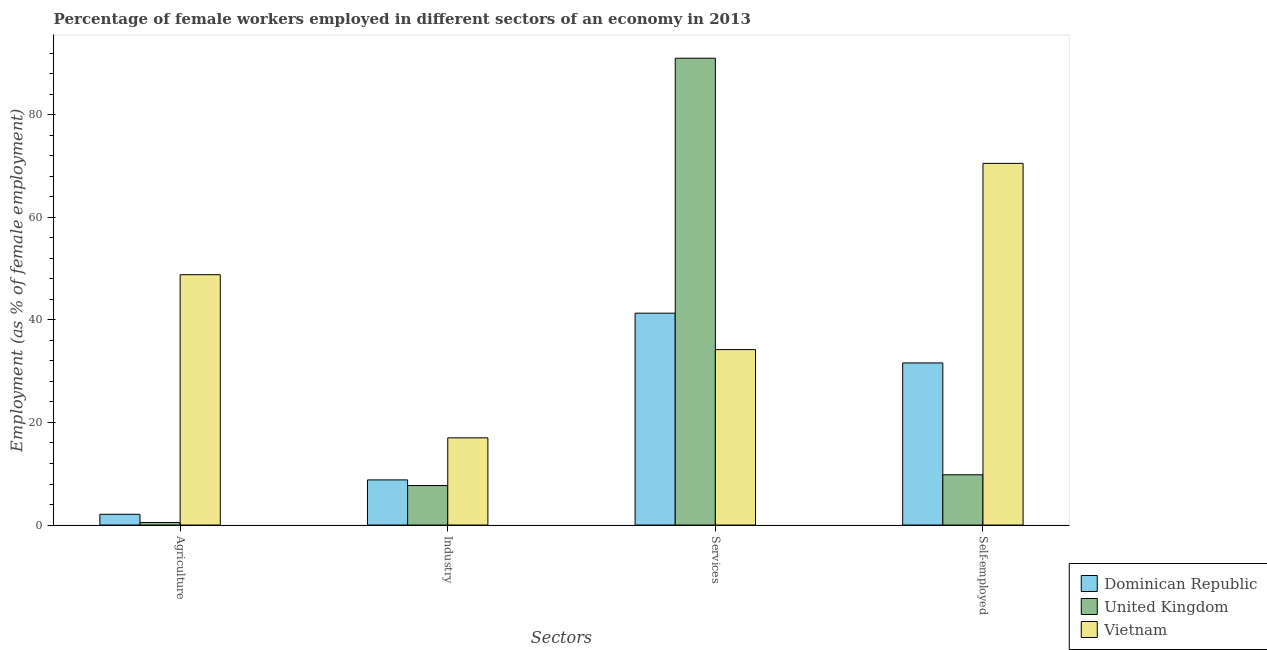Are the number of bars on each tick of the X-axis equal?
Your answer should be very brief. Yes. How many bars are there on the 3rd tick from the left?
Provide a short and direct response. 3. What is the label of the 4th group of bars from the left?
Your response must be concise. Self-employed. What is the percentage of female workers in services in Dominican Republic?
Your answer should be compact. 41.3. Across all countries, what is the maximum percentage of female workers in industry?
Provide a succinct answer. 17. Across all countries, what is the minimum percentage of female workers in agriculture?
Make the answer very short. 0.5. In which country was the percentage of female workers in services maximum?
Provide a short and direct response. United Kingdom. What is the total percentage of female workers in agriculture in the graph?
Your answer should be compact. 51.4. What is the difference between the percentage of female workers in agriculture in United Kingdom and that in Dominican Republic?
Provide a succinct answer. -1.6. What is the difference between the percentage of female workers in industry in Vietnam and the percentage of female workers in agriculture in United Kingdom?
Provide a short and direct response. 16.5. What is the average percentage of female workers in agriculture per country?
Your answer should be very brief. 17.13. What is the difference between the percentage of female workers in services and percentage of female workers in agriculture in Dominican Republic?
Offer a very short reply. 39.2. In how many countries, is the percentage of female workers in industry greater than 80 %?
Your answer should be very brief. 0. What is the ratio of the percentage of self employed female workers in Dominican Republic to that in Vietnam?
Offer a very short reply. 0.45. Is the percentage of self employed female workers in United Kingdom less than that in Dominican Republic?
Your response must be concise. Yes. What is the difference between the highest and the second highest percentage of female workers in services?
Ensure brevity in your answer.  49.7. What is the difference between the highest and the lowest percentage of female workers in services?
Your answer should be very brief. 56.8. In how many countries, is the percentage of self employed female workers greater than the average percentage of self employed female workers taken over all countries?
Your response must be concise. 1. Is the sum of the percentage of female workers in agriculture in Vietnam and United Kingdom greater than the maximum percentage of female workers in services across all countries?
Offer a very short reply. No. Is it the case that in every country, the sum of the percentage of female workers in services and percentage of female workers in industry is greater than the sum of percentage of self employed female workers and percentage of female workers in agriculture?
Provide a succinct answer. No. What does the 1st bar from the left in Industry represents?
Offer a very short reply. Dominican Republic. What does the 3rd bar from the right in Industry represents?
Your response must be concise. Dominican Republic. Is it the case that in every country, the sum of the percentage of female workers in agriculture and percentage of female workers in industry is greater than the percentage of female workers in services?
Your answer should be compact. No. How many bars are there?
Your answer should be compact. 12. Are all the bars in the graph horizontal?
Offer a very short reply. No. What is the difference between two consecutive major ticks on the Y-axis?
Offer a terse response. 20. Are the values on the major ticks of Y-axis written in scientific E-notation?
Your answer should be compact. No. Does the graph contain any zero values?
Your answer should be compact. No. Does the graph contain grids?
Your answer should be compact. No. Where does the legend appear in the graph?
Make the answer very short. Bottom right. How many legend labels are there?
Your answer should be very brief. 3. What is the title of the graph?
Your response must be concise. Percentage of female workers employed in different sectors of an economy in 2013. Does "World" appear as one of the legend labels in the graph?
Offer a very short reply. No. What is the label or title of the X-axis?
Your answer should be compact. Sectors. What is the label or title of the Y-axis?
Offer a very short reply. Employment (as % of female employment). What is the Employment (as % of female employment) in Dominican Republic in Agriculture?
Offer a terse response. 2.1. What is the Employment (as % of female employment) in Vietnam in Agriculture?
Offer a very short reply. 48.8. What is the Employment (as % of female employment) of Dominican Republic in Industry?
Make the answer very short. 8.8. What is the Employment (as % of female employment) in United Kingdom in Industry?
Give a very brief answer. 7.7. What is the Employment (as % of female employment) in Dominican Republic in Services?
Keep it short and to the point. 41.3. What is the Employment (as % of female employment) of United Kingdom in Services?
Provide a succinct answer. 91. What is the Employment (as % of female employment) of Vietnam in Services?
Your response must be concise. 34.2. What is the Employment (as % of female employment) of Dominican Republic in Self-employed?
Give a very brief answer. 31.6. What is the Employment (as % of female employment) in United Kingdom in Self-employed?
Provide a succinct answer. 9.8. What is the Employment (as % of female employment) of Vietnam in Self-employed?
Ensure brevity in your answer.  70.5. Across all Sectors, what is the maximum Employment (as % of female employment) of Dominican Republic?
Provide a short and direct response. 41.3. Across all Sectors, what is the maximum Employment (as % of female employment) of United Kingdom?
Your answer should be very brief. 91. Across all Sectors, what is the maximum Employment (as % of female employment) in Vietnam?
Your answer should be compact. 70.5. Across all Sectors, what is the minimum Employment (as % of female employment) in Dominican Republic?
Keep it short and to the point. 2.1. Across all Sectors, what is the minimum Employment (as % of female employment) in United Kingdom?
Your response must be concise. 0.5. Across all Sectors, what is the minimum Employment (as % of female employment) of Vietnam?
Provide a short and direct response. 17. What is the total Employment (as % of female employment) of Dominican Republic in the graph?
Offer a terse response. 83.8. What is the total Employment (as % of female employment) of United Kingdom in the graph?
Provide a succinct answer. 109. What is the total Employment (as % of female employment) in Vietnam in the graph?
Provide a succinct answer. 170.5. What is the difference between the Employment (as % of female employment) in United Kingdom in Agriculture and that in Industry?
Offer a very short reply. -7.2. What is the difference between the Employment (as % of female employment) in Vietnam in Agriculture and that in Industry?
Offer a very short reply. 31.8. What is the difference between the Employment (as % of female employment) of Dominican Republic in Agriculture and that in Services?
Ensure brevity in your answer.  -39.2. What is the difference between the Employment (as % of female employment) of United Kingdom in Agriculture and that in Services?
Provide a short and direct response. -90.5. What is the difference between the Employment (as % of female employment) of Dominican Republic in Agriculture and that in Self-employed?
Your answer should be compact. -29.5. What is the difference between the Employment (as % of female employment) in United Kingdom in Agriculture and that in Self-employed?
Give a very brief answer. -9.3. What is the difference between the Employment (as % of female employment) of Vietnam in Agriculture and that in Self-employed?
Offer a terse response. -21.7. What is the difference between the Employment (as % of female employment) in Dominican Republic in Industry and that in Services?
Ensure brevity in your answer.  -32.5. What is the difference between the Employment (as % of female employment) in United Kingdom in Industry and that in Services?
Your answer should be very brief. -83.3. What is the difference between the Employment (as % of female employment) of Vietnam in Industry and that in Services?
Provide a succinct answer. -17.2. What is the difference between the Employment (as % of female employment) in Dominican Republic in Industry and that in Self-employed?
Keep it short and to the point. -22.8. What is the difference between the Employment (as % of female employment) of Vietnam in Industry and that in Self-employed?
Make the answer very short. -53.5. What is the difference between the Employment (as % of female employment) in Dominican Republic in Services and that in Self-employed?
Keep it short and to the point. 9.7. What is the difference between the Employment (as % of female employment) in United Kingdom in Services and that in Self-employed?
Your answer should be very brief. 81.2. What is the difference between the Employment (as % of female employment) in Vietnam in Services and that in Self-employed?
Your response must be concise. -36.3. What is the difference between the Employment (as % of female employment) in Dominican Republic in Agriculture and the Employment (as % of female employment) in United Kingdom in Industry?
Make the answer very short. -5.6. What is the difference between the Employment (as % of female employment) of Dominican Republic in Agriculture and the Employment (as % of female employment) of Vietnam in Industry?
Give a very brief answer. -14.9. What is the difference between the Employment (as % of female employment) in United Kingdom in Agriculture and the Employment (as % of female employment) in Vietnam in Industry?
Your response must be concise. -16.5. What is the difference between the Employment (as % of female employment) in Dominican Republic in Agriculture and the Employment (as % of female employment) in United Kingdom in Services?
Your answer should be very brief. -88.9. What is the difference between the Employment (as % of female employment) of Dominican Republic in Agriculture and the Employment (as % of female employment) of Vietnam in Services?
Make the answer very short. -32.1. What is the difference between the Employment (as % of female employment) in United Kingdom in Agriculture and the Employment (as % of female employment) in Vietnam in Services?
Your answer should be compact. -33.7. What is the difference between the Employment (as % of female employment) of Dominican Republic in Agriculture and the Employment (as % of female employment) of United Kingdom in Self-employed?
Provide a succinct answer. -7.7. What is the difference between the Employment (as % of female employment) in Dominican Republic in Agriculture and the Employment (as % of female employment) in Vietnam in Self-employed?
Make the answer very short. -68.4. What is the difference between the Employment (as % of female employment) in United Kingdom in Agriculture and the Employment (as % of female employment) in Vietnam in Self-employed?
Provide a succinct answer. -70. What is the difference between the Employment (as % of female employment) in Dominican Republic in Industry and the Employment (as % of female employment) in United Kingdom in Services?
Make the answer very short. -82.2. What is the difference between the Employment (as % of female employment) in Dominican Republic in Industry and the Employment (as % of female employment) in Vietnam in Services?
Give a very brief answer. -25.4. What is the difference between the Employment (as % of female employment) of United Kingdom in Industry and the Employment (as % of female employment) of Vietnam in Services?
Your response must be concise. -26.5. What is the difference between the Employment (as % of female employment) of Dominican Republic in Industry and the Employment (as % of female employment) of United Kingdom in Self-employed?
Keep it short and to the point. -1. What is the difference between the Employment (as % of female employment) of Dominican Republic in Industry and the Employment (as % of female employment) of Vietnam in Self-employed?
Your answer should be very brief. -61.7. What is the difference between the Employment (as % of female employment) of United Kingdom in Industry and the Employment (as % of female employment) of Vietnam in Self-employed?
Make the answer very short. -62.8. What is the difference between the Employment (as % of female employment) of Dominican Republic in Services and the Employment (as % of female employment) of United Kingdom in Self-employed?
Your answer should be very brief. 31.5. What is the difference between the Employment (as % of female employment) in Dominican Republic in Services and the Employment (as % of female employment) in Vietnam in Self-employed?
Your answer should be compact. -29.2. What is the difference between the Employment (as % of female employment) in United Kingdom in Services and the Employment (as % of female employment) in Vietnam in Self-employed?
Provide a short and direct response. 20.5. What is the average Employment (as % of female employment) in Dominican Republic per Sectors?
Ensure brevity in your answer.  20.95. What is the average Employment (as % of female employment) in United Kingdom per Sectors?
Your response must be concise. 27.25. What is the average Employment (as % of female employment) of Vietnam per Sectors?
Keep it short and to the point. 42.62. What is the difference between the Employment (as % of female employment) in Dominican Republic and Employment (as % of female employment) in United Kingdom in Agriculture?
Give a very brief answer. 1.6. What is the difference between the Employment (as % of female employment) in Dominican Republic and Employment (as % of female employment) in Vietnam in Agriculture?
Provide a short and direct response. -46.7. What is the difference between the Employment (as % of female employment) in United Kingdom and Employment (as % of female employment) in Vietnam in Agriculture?
Keep it short and to the point. -48.3. What is the difference between the Employment (as % of female employment) in Dominican Republic and Employment (as % of female employment) in United Kingdom in Industry?
Make the answer very short. 1.1. What is the difference between the Employment (as % of female employment) of Dominican Republic and Employment (as % of female employment) of Vietnam in Industry?
Keep it short and to the point. -8.2. What is the difference between the Employment (as % of female employment) in Dominican Republic and Employment (as % of female employment) in United Kingdom in Services?
Ensure brevity in your answer.  -49.7. What is the difference between the Employment (as % of female employment) in Dominican Republic and Employment (as % of female employment) in Vietnam in Services?
Ensure brevity in your answer.  7.1. What is the difference between the Employment (as % of female employment) in United Kingdom and Employment (as % of female employment) in Vietnam in Services?
Offer a very short reply. 56.8. What is the difference between the Employment (as % of female employment) of Dominican Republic and Employment (as % of female employment) of United Kingdom in Self-employed?
Offer a very short reply. 21.8. What is the difference between the Employment (as % of female employment) of Dominican Republic and Employment (as % of female employment) of Vietnam in Self-employed?
Your response must be concise. -38.9. What is the difference between the Employment (as % of female employment) of United Kingdom and Employment (as % of female employment) of Vietnam in Self-employed?
Ensure brevity in your answer.  -60.7. What is the ratio of the Employment (as % of female employment) of Dominican Republic in Agriculture to that in Industry?
Keep it short and to the point. 0.24. What is the ratio of the Employment (as % of female employment) of United Kingdom in Agriculture to that in Industry?
Your answer should be compact. 0.06. What is the ratio of the Employment (as % of female employment) in Vietnam in Agriculture to that in Industry?
Offer a very short reply. 2.87. What is the ratio of the Employment (as % of female employment) in Dominican Republic in Agriculture to that in Services?
Give a very brief answer. 0.05. What is the ratio of the Employment (as % of female employment) in United Kingdom in Agriculture to that in Services?
Make the answer very short. 0.01. What is the ratio of the Employment (as % of female employment) in Vietnam in Agriculture to that in Services?
Your answer should be compact. 1.43. What is the ratio of the Employment (as % of female employment) of Dominican Republic in Agriculture to that in Self-employed?
Your answer should be compact. 0.07. What is the ratio of the Employment (as % of female employment) of United Kingdom in Agriculture to that in Self-employed?
Keep it short and to the point. 0.05. What is the ratio of the Employment (as % of female employment) of Vietnam in Agriculture to that in Self-employed?
Make the answer very short. 0.69. What is the ratio of the Employment (as % of female employment) in Dominican Republic in Industry to that in Services?
Provide a succinct answer. 0.21. What is the ratio of the Employment (as % of female employment) of United Kingdom in Industry to that in Services?
Offer a very short reply. 0.08. What is the ratio of the Employment (as % of female employment) of Vietnam in Industry to that in Services?
Keep it short and to the point. 0.5. What is the ratio of the Employment (as % of female employment) in Dominican Republic in Industry to that in Self-employed?
Ensure brevity in your answer.  0.28. What is the ratio of the Employment (as % of female employment) of United Kingdom in Industry to that in Self-employed?
Your response must be concise. 0.79. What is the ratio of the Employment (as % of female employment) of Vietnam in Industry to that in Self-employed?
Offer a very short reply. 0.24. What is the ratio of the Employment (as % of female employment) in Dominican Republic in Services to that in Self-employed?
Provide a succinct answer. 1.31. What is the ratio of the Employment (as % of female employment) of United Kingdom in Services to that in Self-employed?
Give a very brief answer. 9.29. What is the ratio of the Employment (as % of female employment) of Vietnam in Services to that in Self-employed?
Give a very brief answer. 0.49. What is the difference between the highest and the second highest Employment (as % of female employment) of Dominican Republic?
Ensure brevity in your answer.  9.7. What is the difference between the highest and the second highest Employment (as % of female employment) in United Kingdom?
Your answer should be compact. 81.2. What is the difference between the highest and the second highest Employment (as % of female employment) of Vietnam?
Provide a succinct answer. 21.7. What is the difference between the highest and the lowest Employment (as % of female employment) in Dominican Republic?
Make the answer very short. 39.2. What is the difference between the highest and the lowest Employment (as % of female employment) of United Kingdom?
Make the answer very short. 90.5. What is the difference between the highest and the lowest Employment (as % of female employment) in Vietnam?
Ensure brevity in your answer.  53.5. 